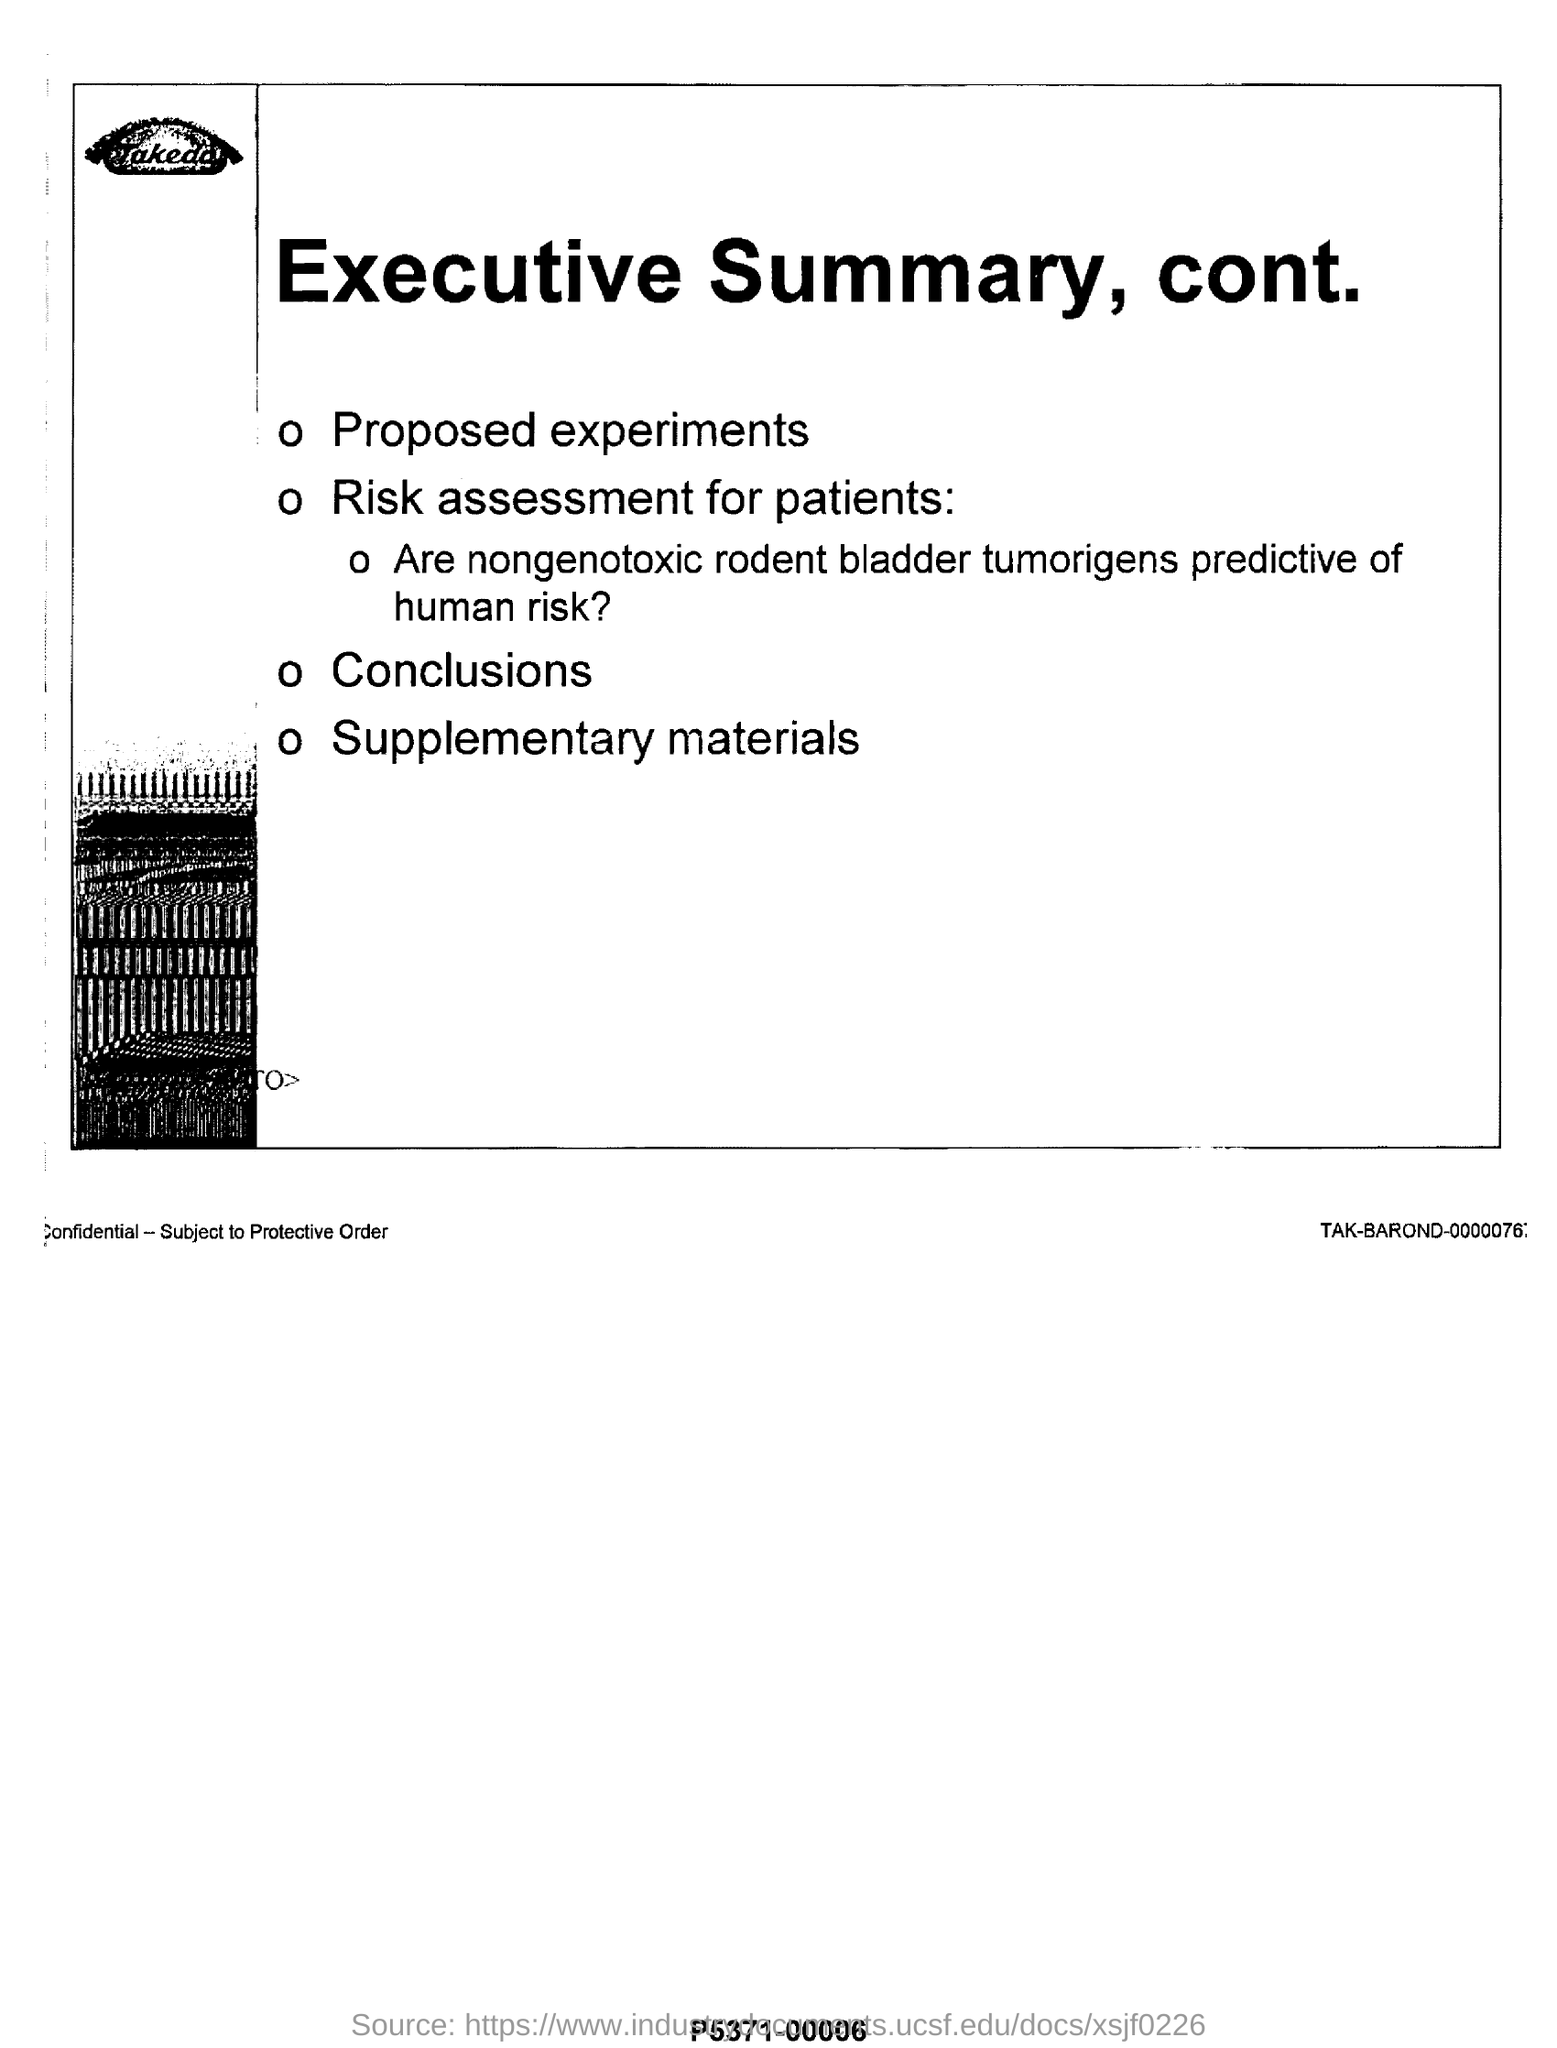What is the title of this page?
Your answer should be very brief. Executive summary, cont. What is the first point under the title-executive summary, cont.
Provide a succinct answer. Proposed experiments. 